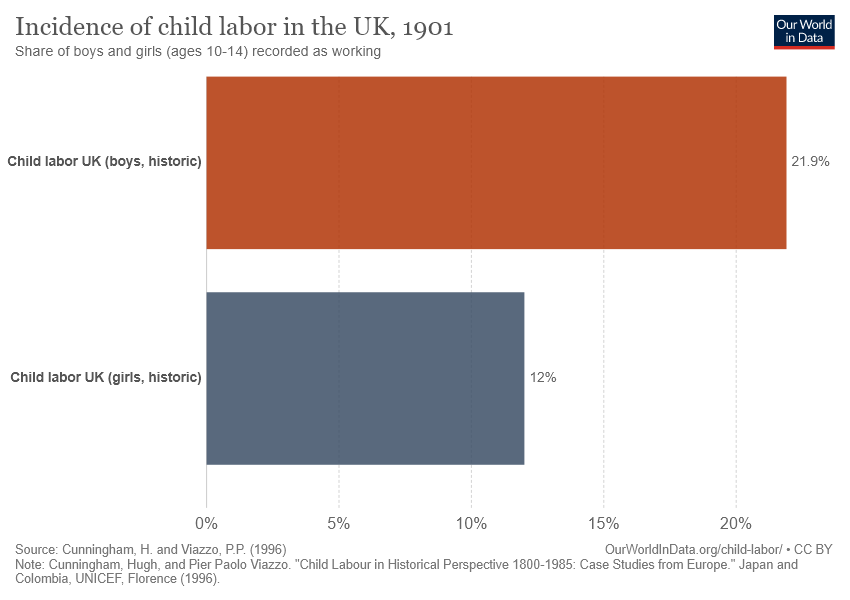Give some essential details in this illustration. The value of the smallest bar is 12. The difference in the value of both bars is 9.9... 